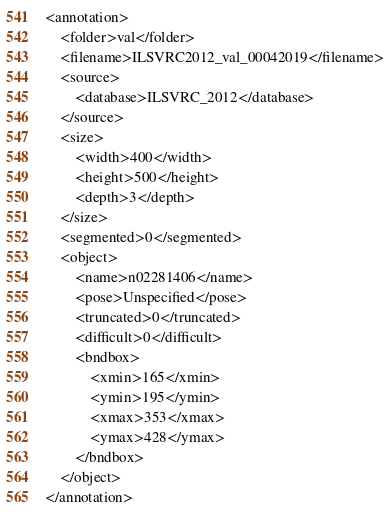Convert code to text. <code><loc_0><loc_0><loc_500><loc_500><_XML_><annotation>
	<folder>val</folder>
	<filename>ILSVRC2012_val_00042019</filename>
	<source>
		<database>ILSVRC_2012</database>
	</source>
	<size>
		<width>400</width>
		<height>500</height>
		<depth>3</depth>
	</size>
	<segmented>0</segmented>
	<object>
		<name>n02281406</name>
		<pose>Unspecified</pose>
		<truncated>0</truncated>
		<difficult>0</difficult>
		<bndbox>
			<xmin>165</xmin>
			<ymin>195</ymin>
			<xmax>353</xmax>
			<ymax>428</ymax>
		</bndbox>
	</object>
</annotation></code> 